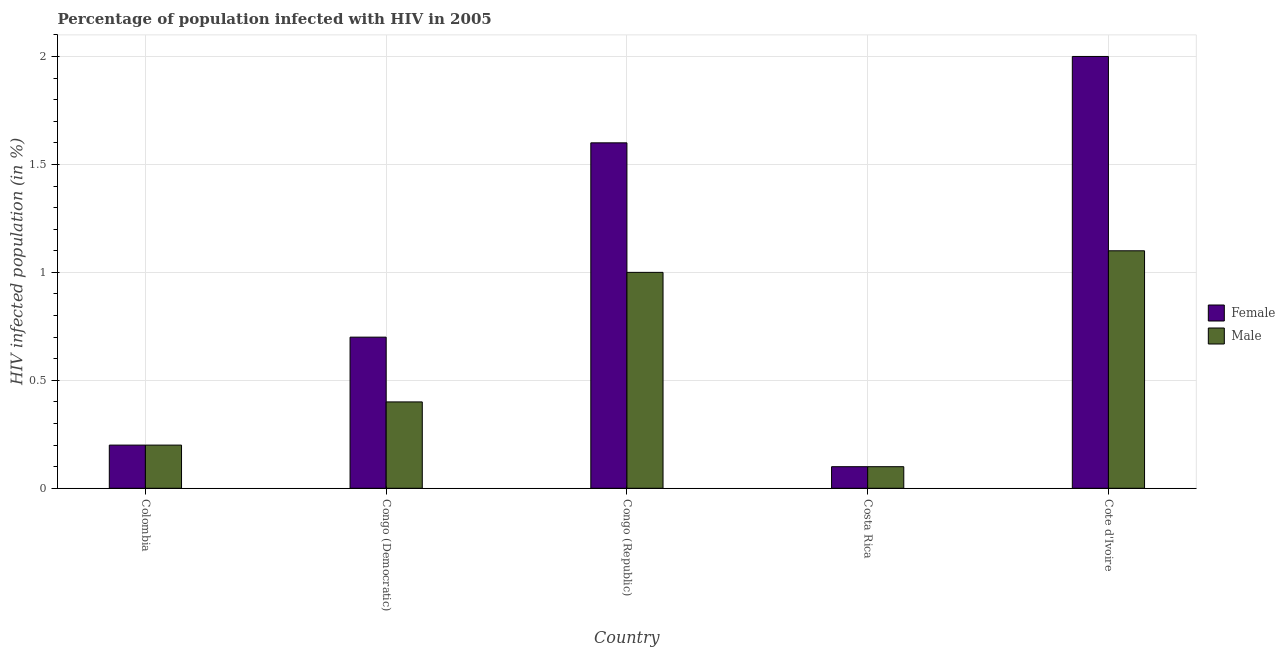How many groups of bars are there?
Provide a succinct answer. 5. How many bars are there on the 4th tick from the right?
Provide a short and direct response. 2. What is the label of the 5th group of bars from the left?
Your answer should be very brief. Cote d'Ivoire. Across all countries, what is the minimum percentage of males who are infected with hiv?
Keep it short and to the point. 0.1. In which country was the percentage of females who are infected with hiv maximum?
Ensure brevity in your answer.  Cote d'Ivoire. In which country was the percentage of males who are infected with hiv minimum?
Your answer should be very brief. Costa Rica. What is the total percentage of males who are infected with hiv in the graph?
Ensure brevity in your answer.  2.8. What is the difference between the percentage of males who are infected with hiv in Colombia and that in Cote d'Ivoire?
Give a very brief answer. -0.9. What is the average percentage of females who are infected with hiv per country?
Make the answer very short. 0.92. What is the difference between the percentage of males who are infected with hiv and percentage of females who are infected with hiv in Cote d'Ivoire?
Provide a succinct answer. -0.9. In how many countries, is the percentage of males who are infected with hiv greater than 0.2 %?
Ensure brevity in your answer.  3. What is the ratio of the percentage of females who are infected with hiv in Congo (Democratic) to that in Congo (Republic)?
Give a very brief answer. 0.44. Is the percentage of females who are infected with hiv in Congo (Democratic) less than that in Costa Rica?
Offer a terse response. No. Is the difference between the percentage of females who are infected with hiv in Congo (Republic) and Costa Rica greater than the difference between the percentage of males who are infected with hiv in Congo (Republic) and Costa Rica?
Offer a very short reply. Yes. What is the difference between the highest and the second highest percentage of females who are infected with hiv?
Offer a very short reply. 0.4. What is the difference between the highest and the lowest percentage of females who are infected with hiv?
Offer a very short reply. 1.9. Is the sum of the percentage of males who are infected with hiv in Congo (Democratic) and Costa Rica greater than the maximum percentage of females who are infected with hiv across all countries?
Give a very brief answer. No. What does the 2nd bar from the left in Cote d'Ivoire represents?
Make the answer very short. Male. What does the 1st bar from the right in Colombia represents?
Give a very brief answer. Male. Are all the bars in the graph horizontal?
Keep it short and to the point. No. Are the values on the major ticks of Y-axis written in scientific E-notation?
Offer a very short reply. No. Does the graph contain any zero values?
Give a very brief answer. No. Does the graph contain grids?
Offer a very short reply. Yes. How many legend labels are there?
Offer a very short reply. 2. What is the title of the graph?
Provide a short and direct response. Percentage of population infected with HIV in 2005. What is the label or title of the X-axis?
Ensure brevity in your answer.  Country. What is the label or title of the Y-axis?
Keep it short and to the point. HIV infected population (in %). What is the HIV infected population (in %) of Female in Colombia?
Make the answer very short. 0.2. What is the HIV infected population (in %) of Female in Congo (Democratic)?
Give a very brief answer. 0.7. What is the HIV infected population (in %) of Male in Congo (Democratic)?
Ensure brevity in your answer.  0.4. What is the HIV infected population (in %) in Male in Congo (Republic)?
Ensure brevity in your answer.  1. What is the HIV infected population (in %) in Male in Costa Rica?
Your answer should be compact. 0.1. What is the HIV infected population (in %) in Female in Cote d'Ivoire?
Ensure brevity in your answer.  2. Across all countries, what is the minimum HIV infected population (in %) of Female?
Provide a succinct answer. 0.1. What is the total HIV infected population (in %) in Female in the graph?
Make the answer very short. 4.6. What is the difference between the HIV infected population (in %) of Male in Colombia and that in Congo (Democratic)?
Your answer should be compact. -0.2. What is the difference between the HIV infected population (in %) of Female in Colombia and that in Congo (Republic)?
Offer a very short reply. -1.4. What is the difference between the HIV infected population (in %) in Male in Colombia and that in Costa Rica?
Your answer should be compact. 0.1. What is the difference between the HIV infected population (in %) in Male in Colombia and that in Cote d'Ivoire?
Give a very brief answer. -0.9. What is the difference between the HIV infected population (in %) of Female in Congo (Democratic) and that in Congo (Republic)?
Offer a terse response. -0.9. What is the difference between the HIV infected population (in %) of Male in Congo (Democratic) and that in Congo (Republic)?
Offer a very short reply. -0.6. What is the difference between the HIV infected population (in %) in Female in Congo (Democratic) and that in Costa Rica?
Your response must be concise. 0.6. What is the difference between the HIV infected population (in %) of Male in Congo (Democratic) and that in Costa Rica?
Provide a succinct answer. 0.3. What is the difference between the HIV infected population (in %) of Male in Congo (Republic) and that in Costa Rica?
Your answer should be compact. 0.9. What is the difference between the HIV infected population (in %) of Male in Congo (Republic) and that in Cote d'Ivoire?
Provide a short and direct response. -0.1. What is the difference between the HIV infected population (in %) of Female in Costa Rica and that in Cote d'Ivoire?
Offer a terse response. -1.9. What is the difference between the HIV infected population (in %) of Male in Costa Rica and that in Cote d'Ivoire?
Keep it short and to the point. -1. What is the difference between the HIV infected population (in %) of Female in Colombia and the HIV infected population (in %) of Male in Cote d'Ivoire?
Your answer should be very brief. -0.9. What is the difference between the HIV infected population (in %) of Female in Congo (Democratic) and the HIV infected population (in %) of Male in Cote d'Ivoire?
Make the answer very short. -0.4. What is the difference between the HIV infected population (in %) of Female in Congo (Republic) and the HIV infected population (in %) of Male in Costa Rica?
Give a very brief answer. 1.5. What is the average HIV infected population (in %) in Female per country?
Offer a terse response. 0.92. What is the average HIV infected population (in %) of Male per country?
Ensure brevity in your answer.  0.56. What is the difference between the HIV infected population (in %) of Female and HIV infected population (in %) of Male in Colombia?
Your answer should be very brief. 0. What is the difference between the HIV infected population (in %) of Female and HIV infected population (in %) of Male in Costa Rica?
Your answer should be very brief. 0. What is the ratio of the HIV infected population (in %) in Female in Colombia to that in Congo (Democratic)?
Ensure brevity in your answer.  0.29. What is the ratio of the HIV infected population (in %) in Male in Colombia to that in Cote d'Ivoire?
Make the answer very short. 0.18. What is the ratio of the HIV infected population (in %) of Female in Congo (Democratic) to that in Congo (Republic)?
Offer a very short reply. 0.44. What is the ratio of the HIV infected population (in %) in Male in Congo (Democratic) to that in Congo (Republic)?
Offer a terse response. 0.4. What is the ratio of the HIV infected population (in %) of Female in Congo (Democratic) to that in Cote d'Ivoire?
Make the answer very short. 0.35. What is the ratio of the HIV infected population (in %) of Male in Congo (Democratic) to that in Cote d'Ivoire?
Offer a terse response. 0.36. What is the ratio of the HIV infected population (in %) in Female in Congo (Republic) to that in Cote d'Ivoire?
Your response must be concise. 0.8. What is the ratio of the HIV infected population (in %) of Female in Costa Rica to that in Cote d'Ivoire?
Make the answer very short. 0.05. What is the ratio of the HIV infected population (in %) in Male in Costa Rica to that in Cote d'Ivoire?
Provide a short and direct response. 0.09. What is the difference between the highest and the lowest HIV infected population (in %) in Male?
Offer a terse response. 1. 